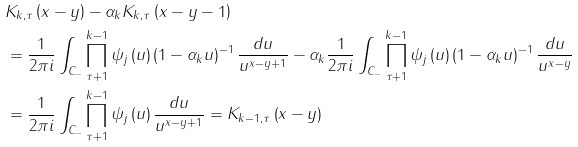<formula> <loc_0><loc_0><loc_500><loc_500>& K _ { k , \tau } \left ( x - y \right ) - \alpha _ { k } K _ { k , \tau } \left ( x - y - 1 \right ) \\ & = \frac { 1 } { 2 \pi i } \int _ { C _ { - } } \prod _ { \tau + 1 } ^ { k - 1 } \psi _ { j } \left ( u \right ) \left ( 1 - \alpha _ { k } u \right ) ^ { - 1 } \frac { d u } { u ^ { x - y + 1 } } - \alpha _ { k } \frac { 1 } { 2 \pi i } \int _ { C _ { - } } \prod _ { \tau + 1 } ^ { k - 1 } \psi _ { j } \left ( u \right ) \left ( 1 - \alpha _ { k } u \right ) ^ { - 1 } \frac { d u } { u ^ { x - y } } \\ & = \frac { 1 } { 2 \pi i } \int _ { C _ { - } } \prod _ { \tau + 1 } ^ { k - 1 } \psi _ { j } \left ( u \right ) \frac { d u } { u ^ { x - y + 1 } } = K _ { k - 1 , \tau } \left ( x - y \right )</formula> 